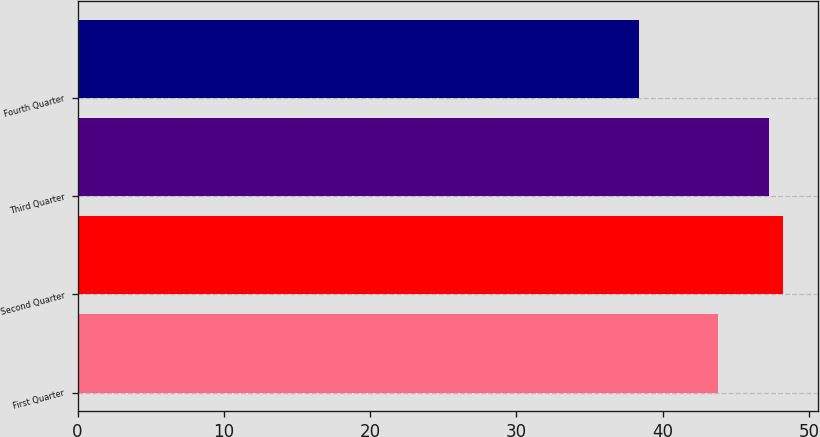Convert chart to OTSL. <chart><loc_0><loc_0><loc_500><loc_500><bar_chart><fcel>First Quarter<fcel>Second Quarter<fcel>Third Quarter<fcel>Fourth Quarter<nl><fcel>43.78<fcel>48.19<fcel>47.28<fcel>38.36<nl></chart> 